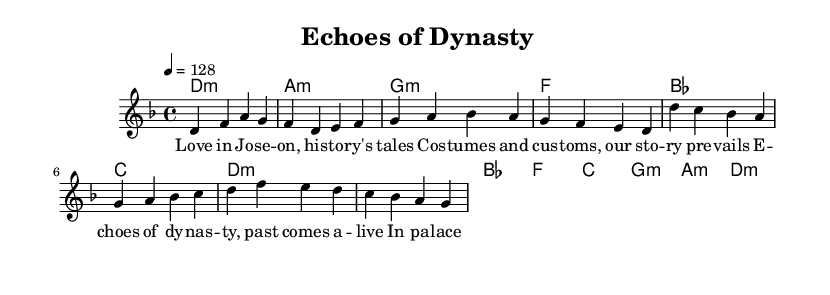What is the key signature of this music? The key signature indicated in the global section of the sheet music is D minor, which has one flat.
Answer: D minor What is the time signature of this piece? The time signature shown in the global section is 4/4, meaning there are four beats in each measure.
Answer: 4/4 What is the tempo marking for this piece? The tempo marking specifies a speed of 128 beats per minute, indicating how fast the piece should be played.
Answer: 128 How many measures are in the verse section? The verse section is made up of four measures, as indicated by the number of musical phrases listed.
Answer: 4 Identify a recurring musical element in the chorus. In the chorus, the melody consistently starts on the keynote note, D, which creates a sense of familiarity and unity.
Answer: D What is a characteristic feature of K-Pop reflected in the lyrics? The lyrics emphasize historical storytelling and elements that connect to visual aesthetics, commonly found in K-Pop music videos showcasing historical themes.
Answer: Historical storytelling What type of chords are primarily used in the harmonies? The harmonies consist mostly of minor chords, creating a darker, more emotive sound typical in certain K-Pop genres when expressing deeper sentiments.
Answer: Minor chords 